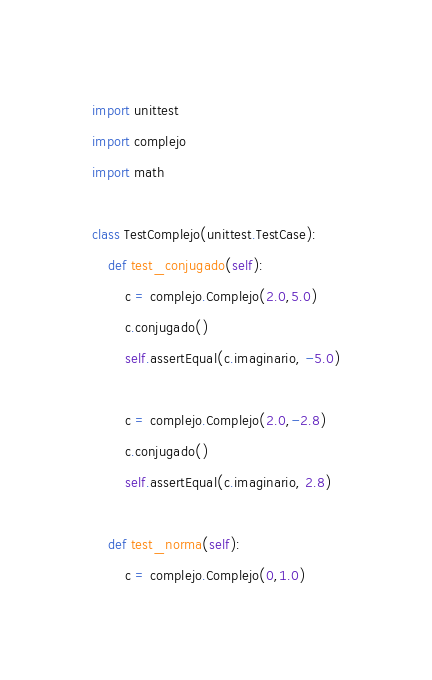<code> <loc_0><loc_0><loc_500><loc_500><_Python_>import unittest
import complejo
import math

class TestComplejo(unittest.TestCase):
    def test_conjugado(self):
        c = complejo.Complejo(2.0,5.0)
        c.conjugado()
        self.assertEqual(c.imaginario, -5.0)

        c = complejo.Complejo(2.0,-2.8)
        c.conjugado()
        self.assertEqual(c.imaginario, 2.8)

    def test_norma(self):
        c = complejo.Complejo(0,1.0)</code> 